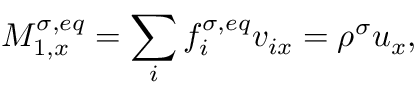<formula> <loc_0><loc_0><loc_500><loc_500>M _ { 1 , x } ^ { \sigma , e q } = \sum _ { i } f _ { i } ^ { \sigma , e q } v _ { i x } = \rho ^ { \sigma } u _ { x } ,</formula> 